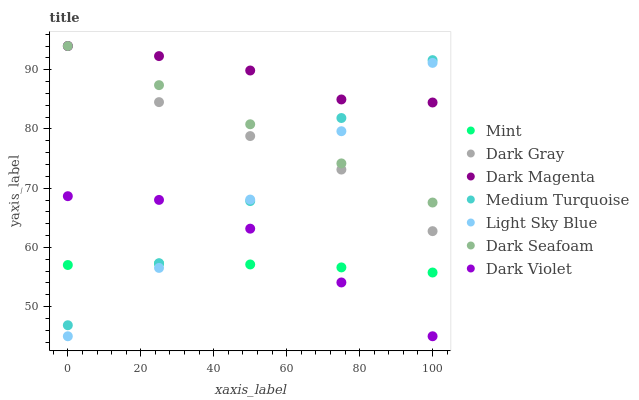Does Mint have the minimum area under the curve?
Answer yes or no. Yes. Does Dark Magenta have the maximum area under the curve?
Answer yes or no. Yes. Does Dark Violet have the minimum area under the curve?
Answer yes or no. No. Does Dark Violet have the maximum area under the curve?
Answer yes or no. No. Is Light Sky Blue the smoothest?
Answer yes or no. Yes. Is Dark Gray the roughest?
Answer yes or no. Yes. Is Dark Violet the smoothest?
Answer yes or no. No. Is Dark Violet the roughest?
Answer yes or no. No. Does Dark Violet have the lowest value?
Answer yes or no. Yes. Does Dark Gray have the lowest value?
Answer yes or no. No. Does Dark Seafoam have the highest value?
Answer yes or no. Yes. Does Dark Violet have the highest value?
Answer yes or no. No. Is Dark Violet less than Dark Gray?
Answer yes or no. Yes. Is Dark Magenta greater than Mint?
Answer yes or no. Yes. Does Dark Seafoam intersect Medium Turquoise?
Answer yes or no. Yes. Is Dark Seafoam less than Medium Turquoise?
Answer yes or no. No. Is Dark Seafoam greater than Medium Turquoise?
Answer yes or no. No. Does Dark Violet intersect Dark Gray?
Answer yes or no. No. 